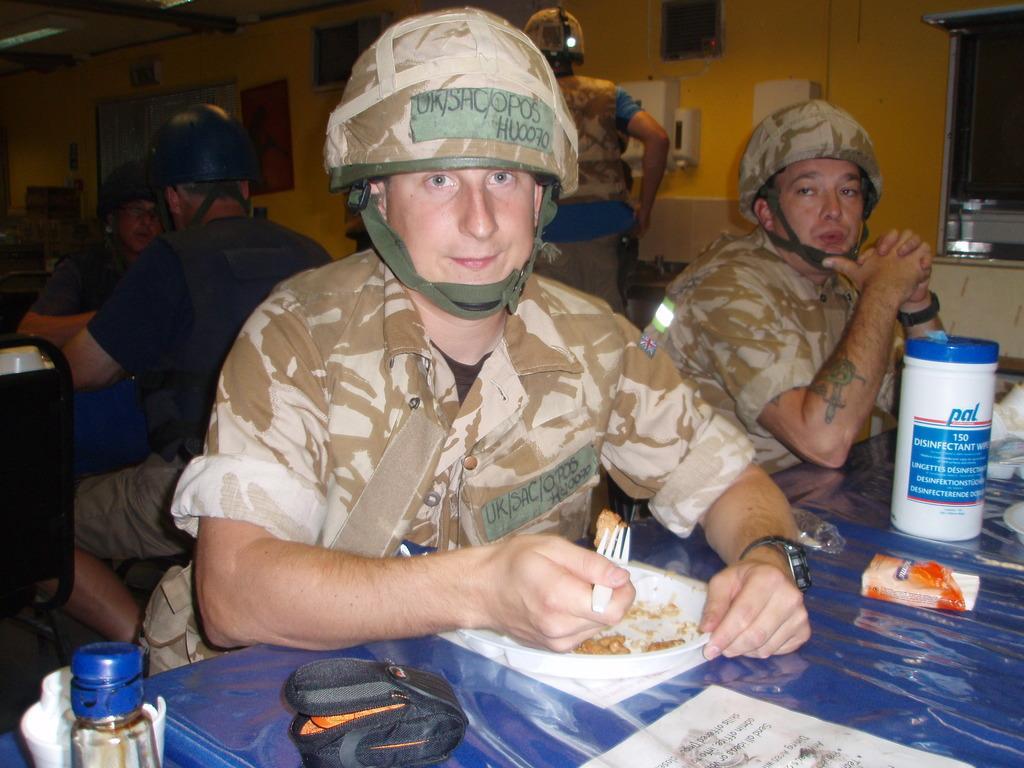Could you give a brief overview of what you see in this image? In this picture I can observe some people sitting on the chairs in front of their respective tables. I can observe few things placed on the table. All of them are wearing helmets on their heads. In the background I can observe wall. 